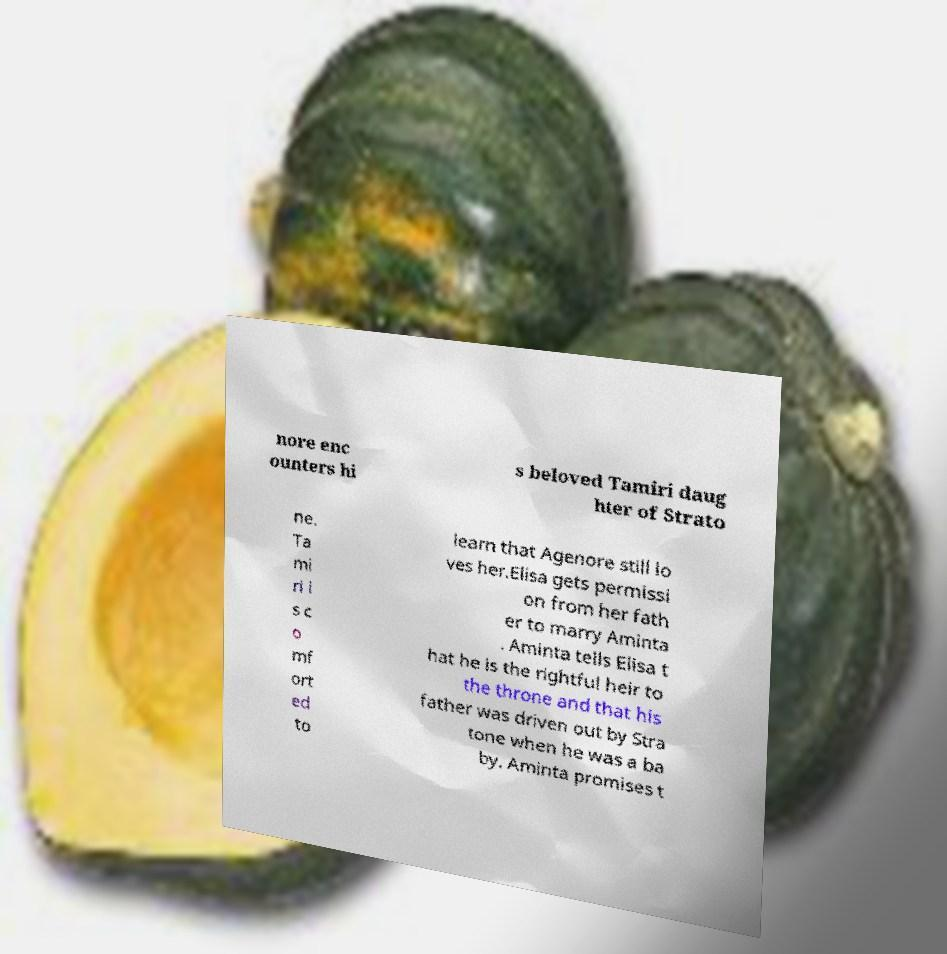What messages or text are displayed in this image? I need them in a readable, typed format. nore enc ounters hi s beloved Tamiri daug hter of Strato ne. Ta mi ri i s c o mf ort ed to learn that Agenore still lo ves her.Elisa gets permissi on from her fath er to marry Aminta . Aminta tells Elisa t hat he is the rightful heir to the throne and that his father was driven out by Stra tone when he was a ba by. Aminta promises t 